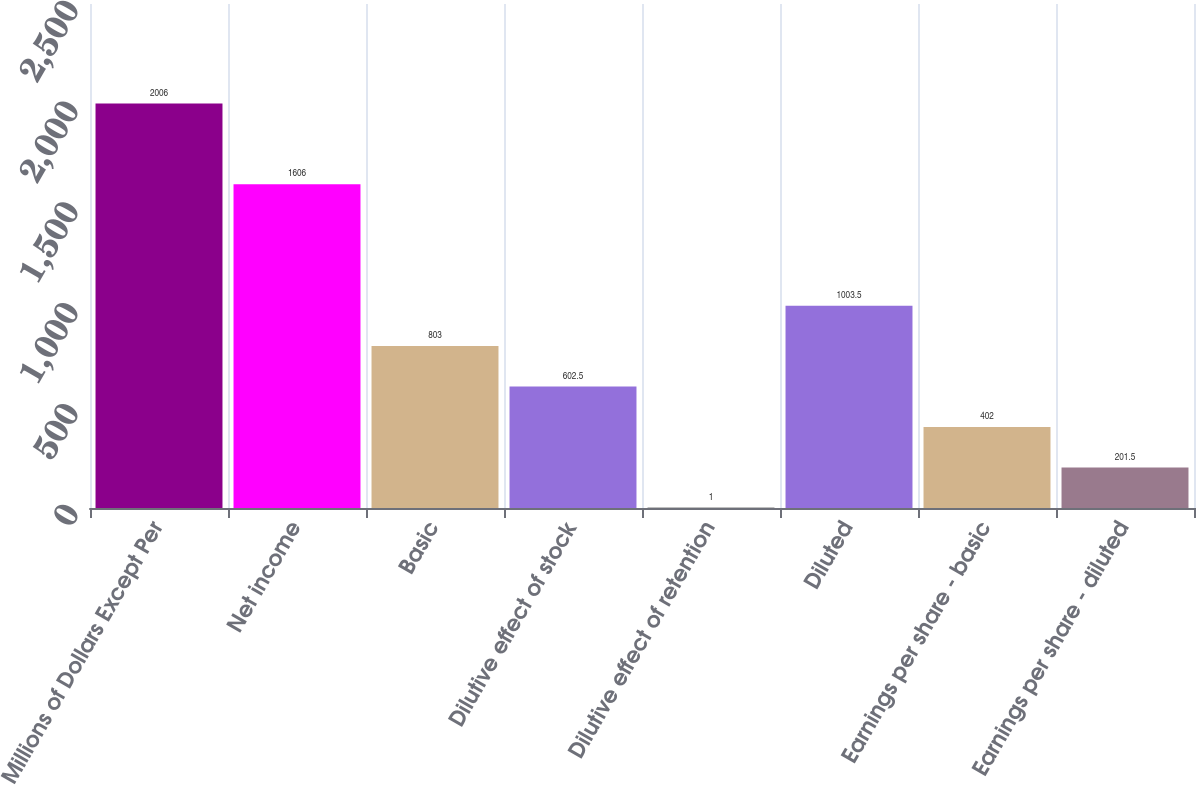Convert chart. <chart><loc_0><loc_0><loc_500><loc_500><bar_chart><fcel>Millions of Dollars Except Per<fcel>Net income<fcel>Basic<fcel>Dilutive effect of stock<fcel>Dilutive effect of retention<fcel>Diluted<fcel>Earnings per share - basic<fcel>Earnings per share - diluted<nl><fcel>2006<fcel>1606<fcel>803<fcel>602.5<fcel>1<fcel>1003.5<fcel>402<fcel>201.5<nl></chart> 